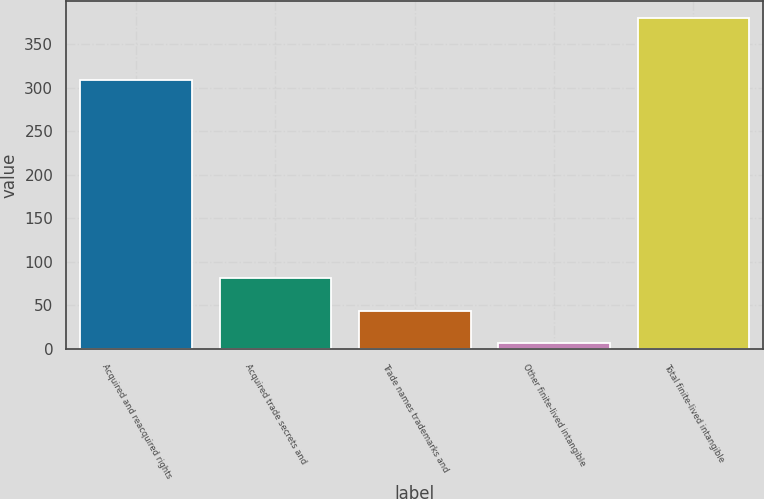Convert chart. <chart><loc_0><loc_0><loc_500><loc_500><bar_chart><fcel>Acquired and reacquired rights<fcel>Acquired trade secrets and<fcel>Trade names trademarks and<fcel>Other finite-lived intangible<fcel>Total finite-lived intangible<nl><fcel>308.6<fcel>81.32<fcel>43.91<fcel>6.5<fcel>380.6<nl></chart> 